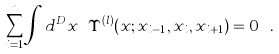Convert formula to latex. <formula><loc_0><loc_0><loc_500><loc_500>\sum _ { i = 1 } ^ { n } \int d ^ { D } x \ \Upsilon ^ { ( l ) } ( x ; x _ { i - 1 } , x _ { i } , x _ { i + 1 } ) = 0 \ .</formula> 